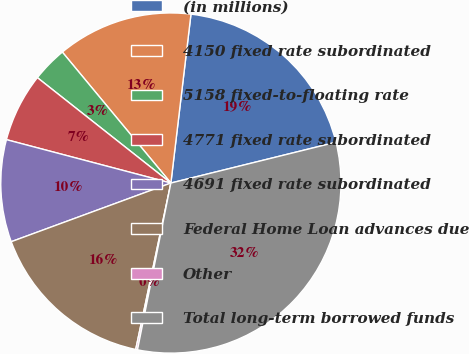Convert chart. <chart><loc_0><loc_0><loc_500><loc_500><pie_chart><fcel>(in millions)<fcel>4150 fixed rate subordinated<fcel>5158 fixed-to-floating rate<fcel>4771 fixed rate subordinated<fcel>4691 fixed rate subordinated<fcel>Federal Home Loan advances due<fcel>Other<fcel>Total long-term borrowed funds<nl><fcel>19.26%<fcel>12.9%<fcel>3.35%<fcel>6.53%<fcel>9.71%<fcel>16.08%<fcel>0.17%<fcel>32.0%<nl></chart> 